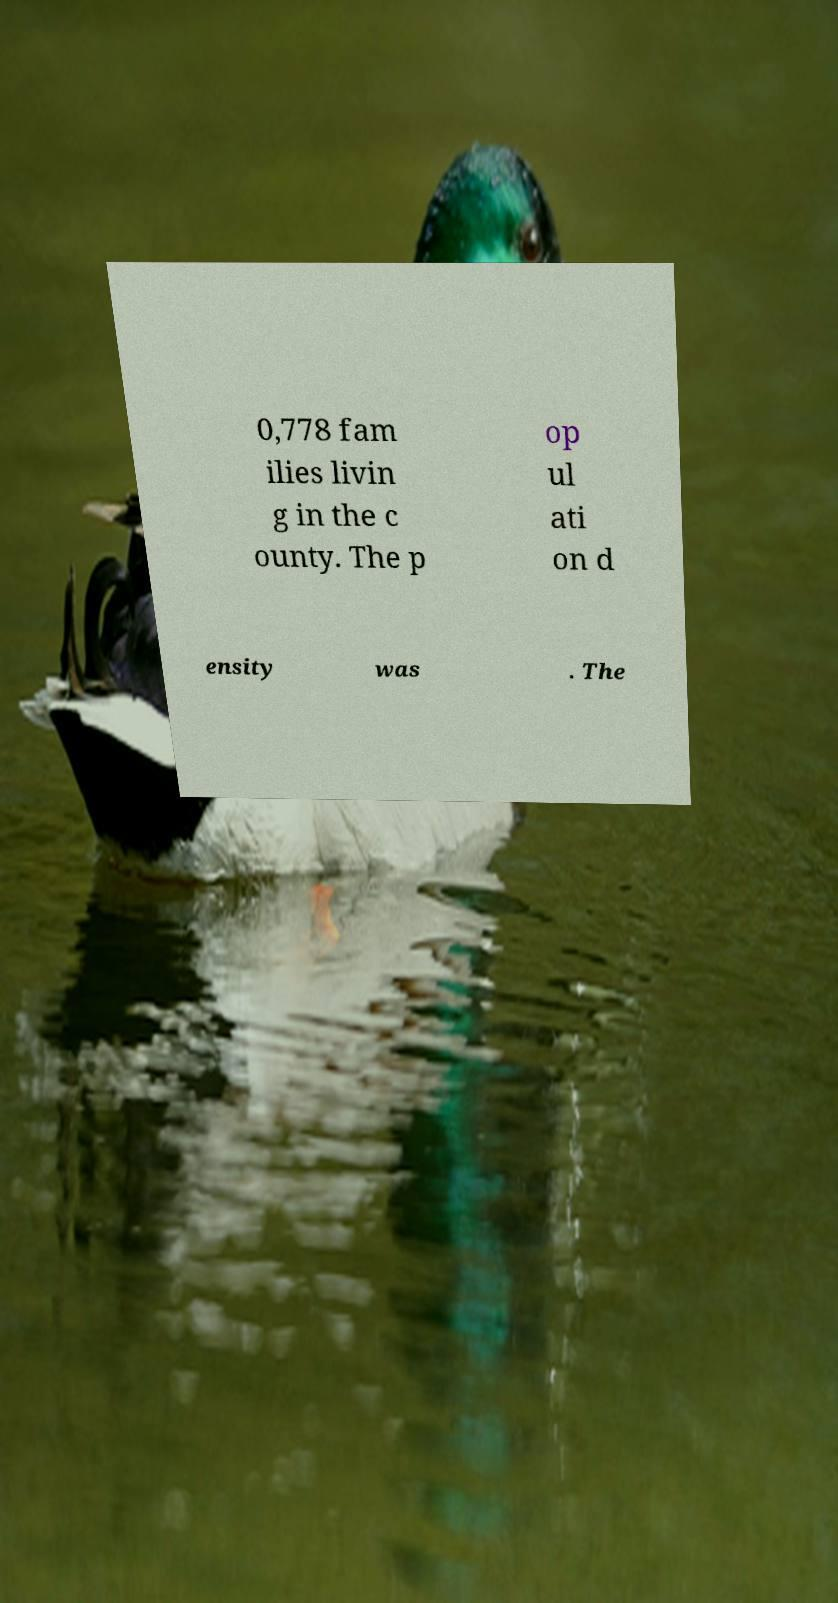Can you accurately transcribe the text from the provided image for me? 0,778 fam ilies livin g in the c ounty. The p op ul ati on d ensity was . The 